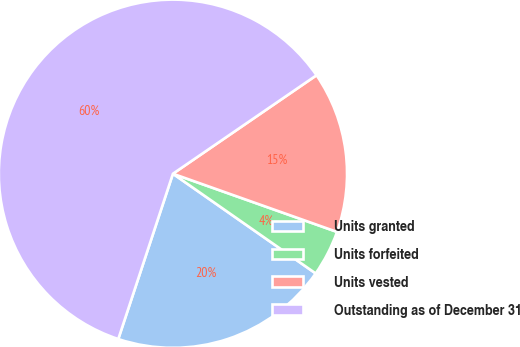Convert chart. <chart><loc_0><loc_0><loc_500><loc_500><pie_chart><fcel>Units granted<fcel>Units forfeited<fcel>Units vested<fcel>Outstanding as of December 31<nl><fcel>20.38%<fcel>4.28%<fcel>14.99%<fcel>60.35%<nl></chart> 